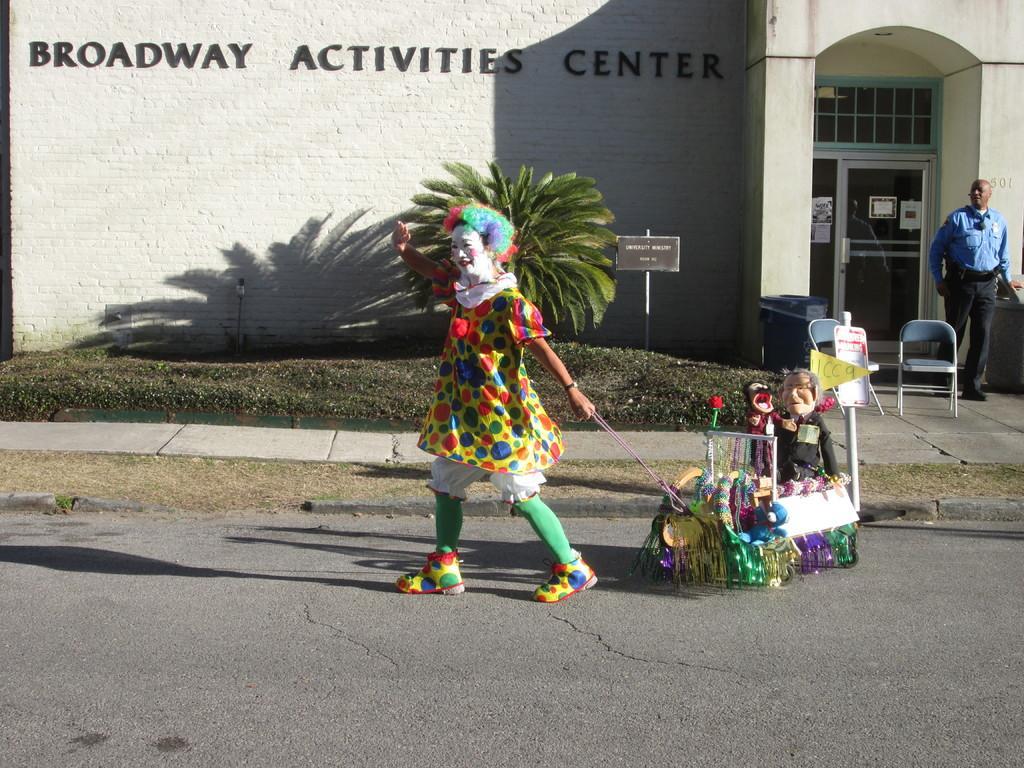Can you describe this image briefly? This picture is clicked outside. In the center we can see a person wearing a costume, holding a rope which is attached to a vehicle, walking on the ground and seems to be pulling the vehicle with the help of the rope and we can see the toys and some objects on the vehicle. In the background we can see the grass, plant, text on the board and the building and we can see the text on the building. On the right there is a person seems to be standing on the ground and we can see the chairs, door of the building and we can see some objects. 